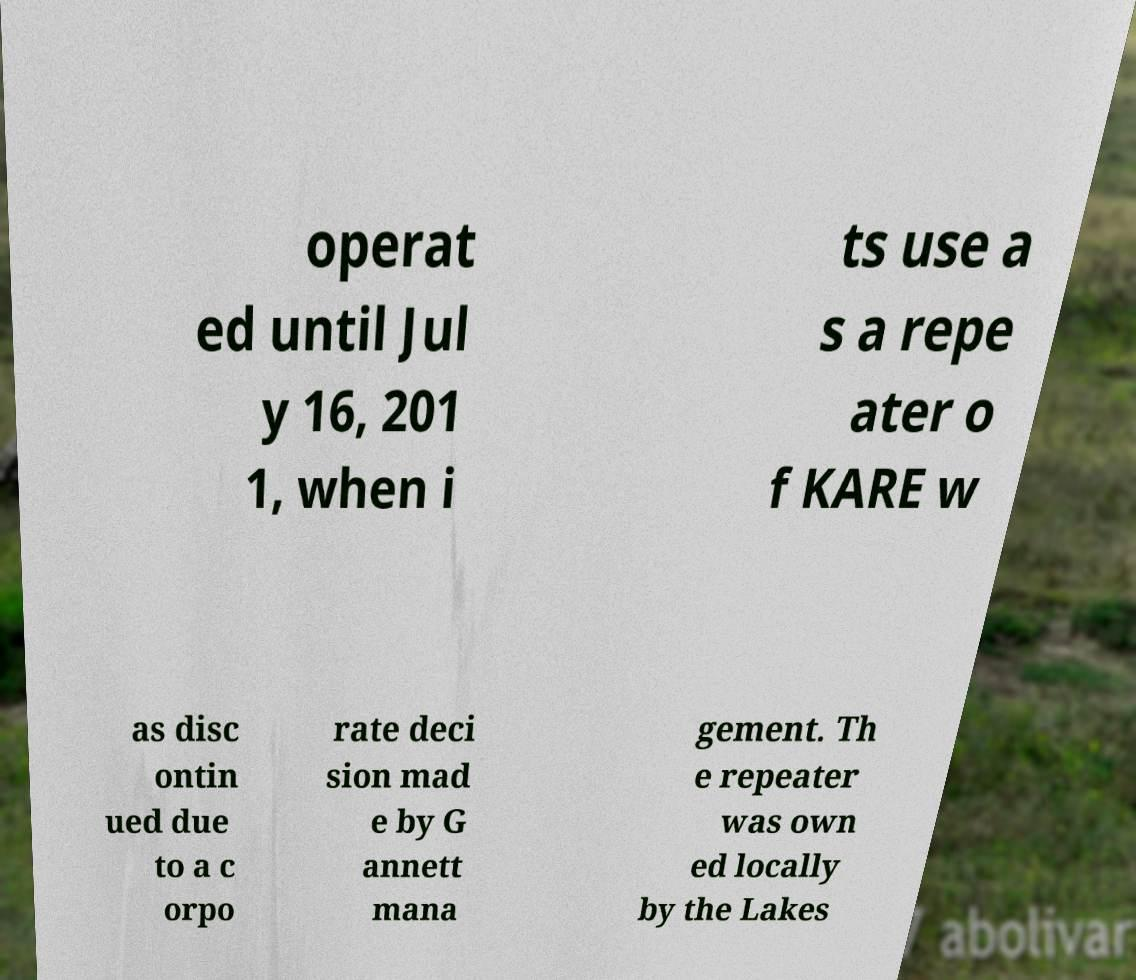Could you extract and type out the text from this image? operat ed until Jul y 16, 201 1, when i ts use a s a repe ater o f KARE w as disc ontin ued due to a c orpo rate deci sion mad e by G annett mana gement. Th e repeater was own ed locally by the Lakes 